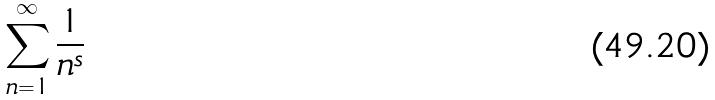<formula> <loc_0><loc_0><loc_500><loc_500>\sum _ { n = 1 } ^ { \infty } \frac { 1 } { n ^ { s } }</formula> 